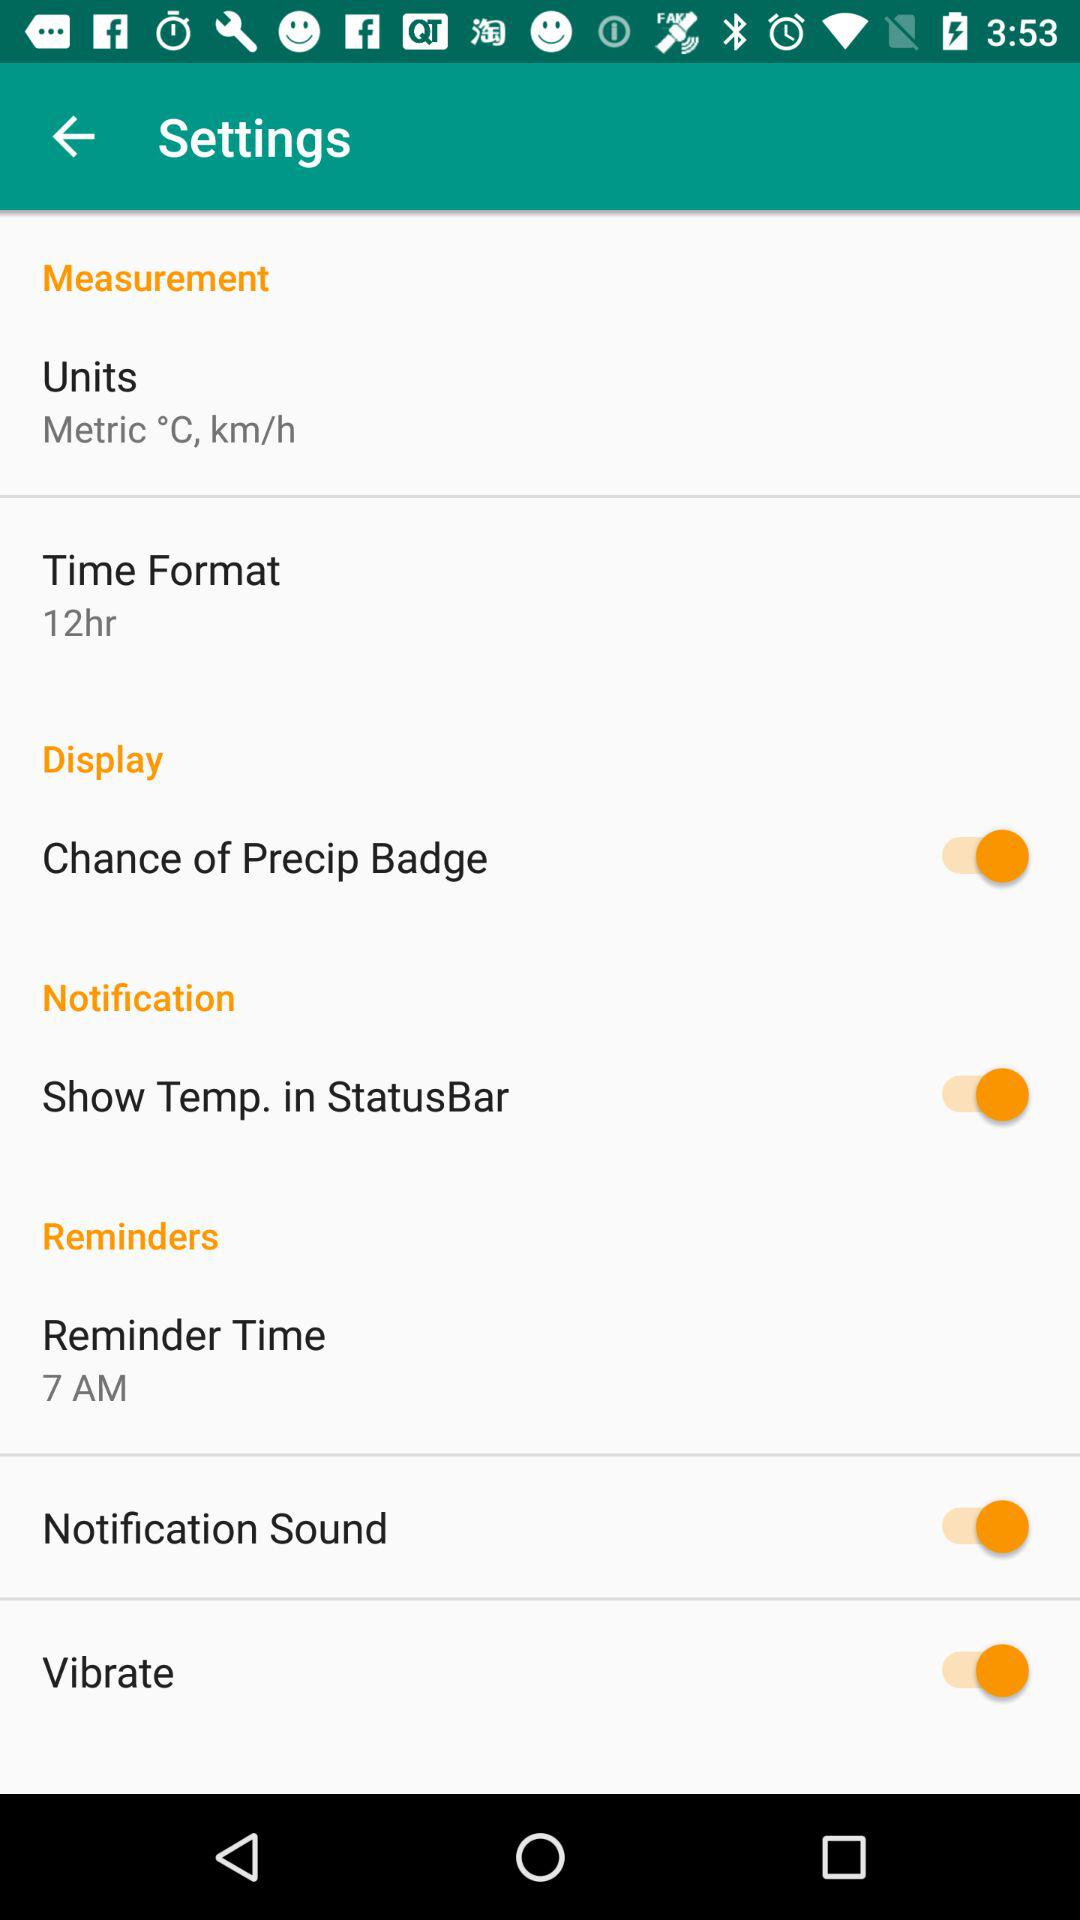What are the units? The units are metric degrees Celsius and kilometers per hour. 